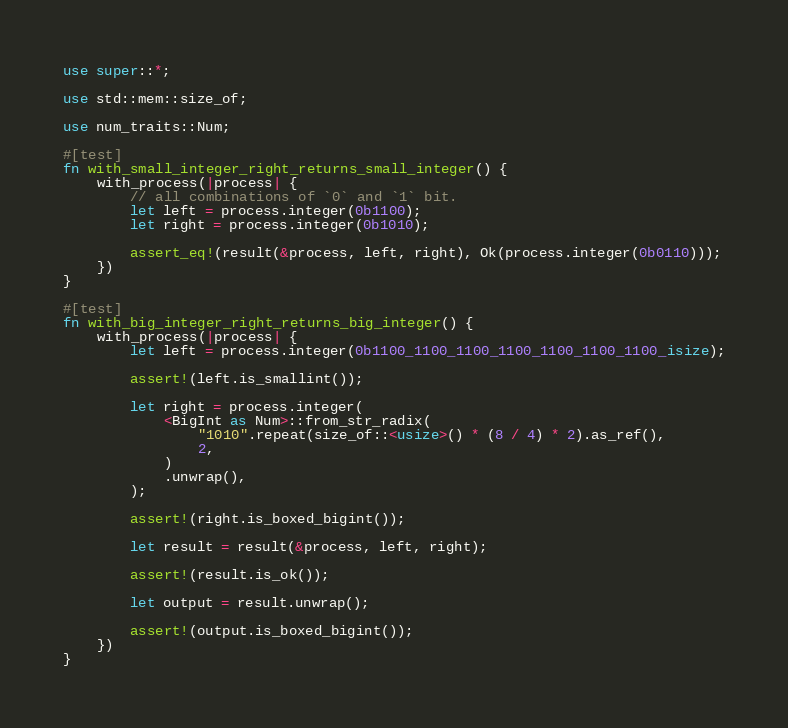<code> <loc_0><loc_0><loc_500><loc_500><_Rust_>use super::*;

use std::mem::size_of;

use num_traits::Num;

#[test]
fn with_small_integer_right_returns_small_integer() {
    with_process(|process| {
        // all combinations of `0` and `1` bit.
        let left = process.integer(0b1100);
        let right = process.integer(0b1010);

        assert_eq!(result(&process, left, right), Ok(process.integer(0b0110)));
    })
}

#[test]
fn with_big_integer_right_returns_big_integer() {
    with_process(|process| {
        let left = process.integer(0b1100_1100_1100_1100_1100_1100_1100_isize);

        assert!(left.is_smallint());

        let right = process.integer(
            <BigInt as Num>::from_str_radix(
                "1010".repeat(size_of::<usize>() * (8 / 4) * 2).as_ref(),
                2,
            )
            .unwrap(),
        );

        assert!(right.is_boxed_bigint());

        let result = result(&process, left, right);

        assert!(result.is_ok());

        let output = result.unwrap();

        assert!(output.is_boxed_bigint());
    })
}
</code> 